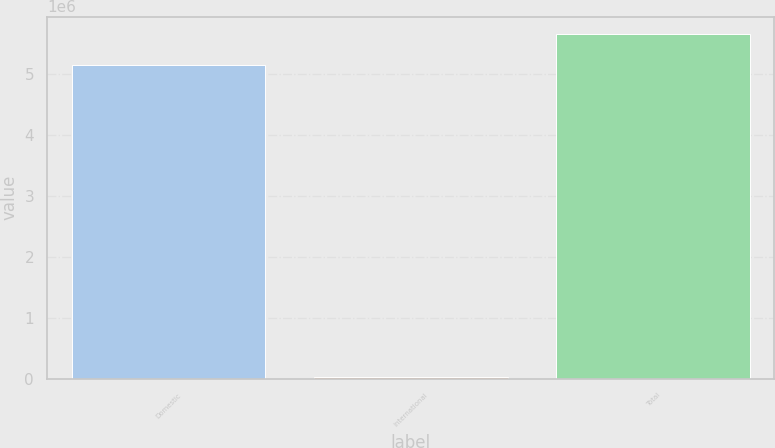Convert chart to OTSL. <chart><loc_0><loc_0><loc_500><loc_500><bar_chart><fcel>Domestic<fcel>International<fcel>Total<nl><fcel>5.14553e+06<fcel>25513<fcel>5.66008e+06<nl></chart> 